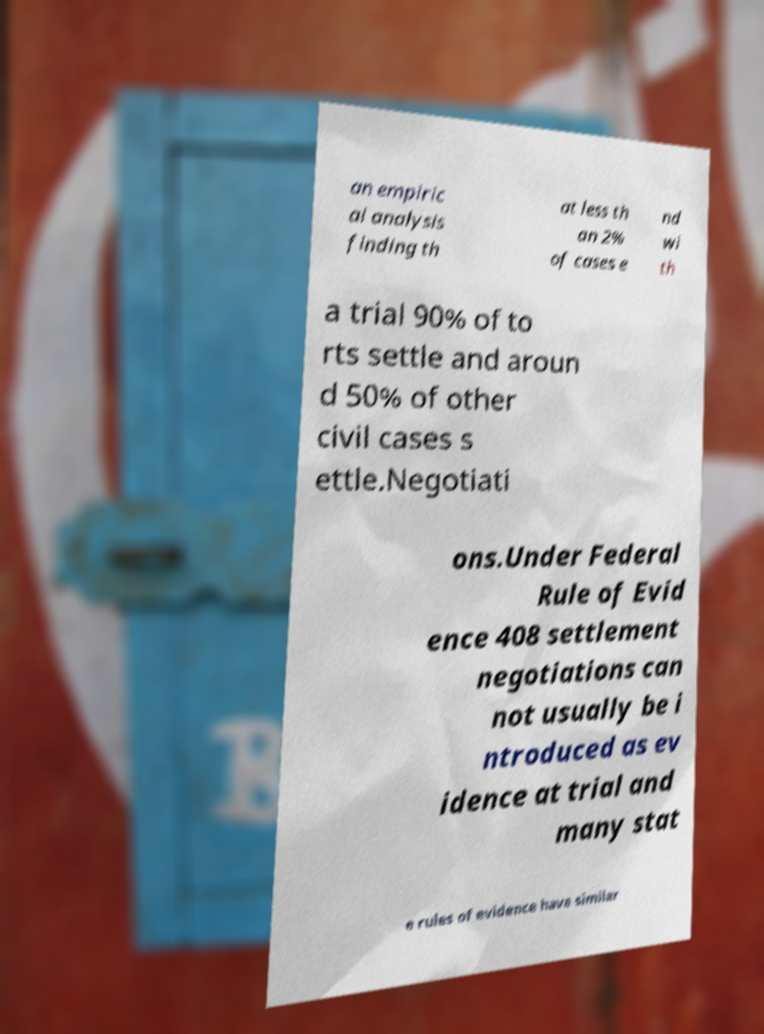Can you read and provide the text displayed in the image?This photo seems to have some interesting text. Can you extract and type it out for me? an empiric al analysis finding th at less th an 2% of cases e nd wi th a trial 90% of to rts settle and aroun d 50% of other civil cases s ettle.Negotiati ons.Under Federal Rule of Evid ence 408 settlement negotiations can not usually be i ntroduced as ev idence at trial and many stat e rules of evidence have similar 